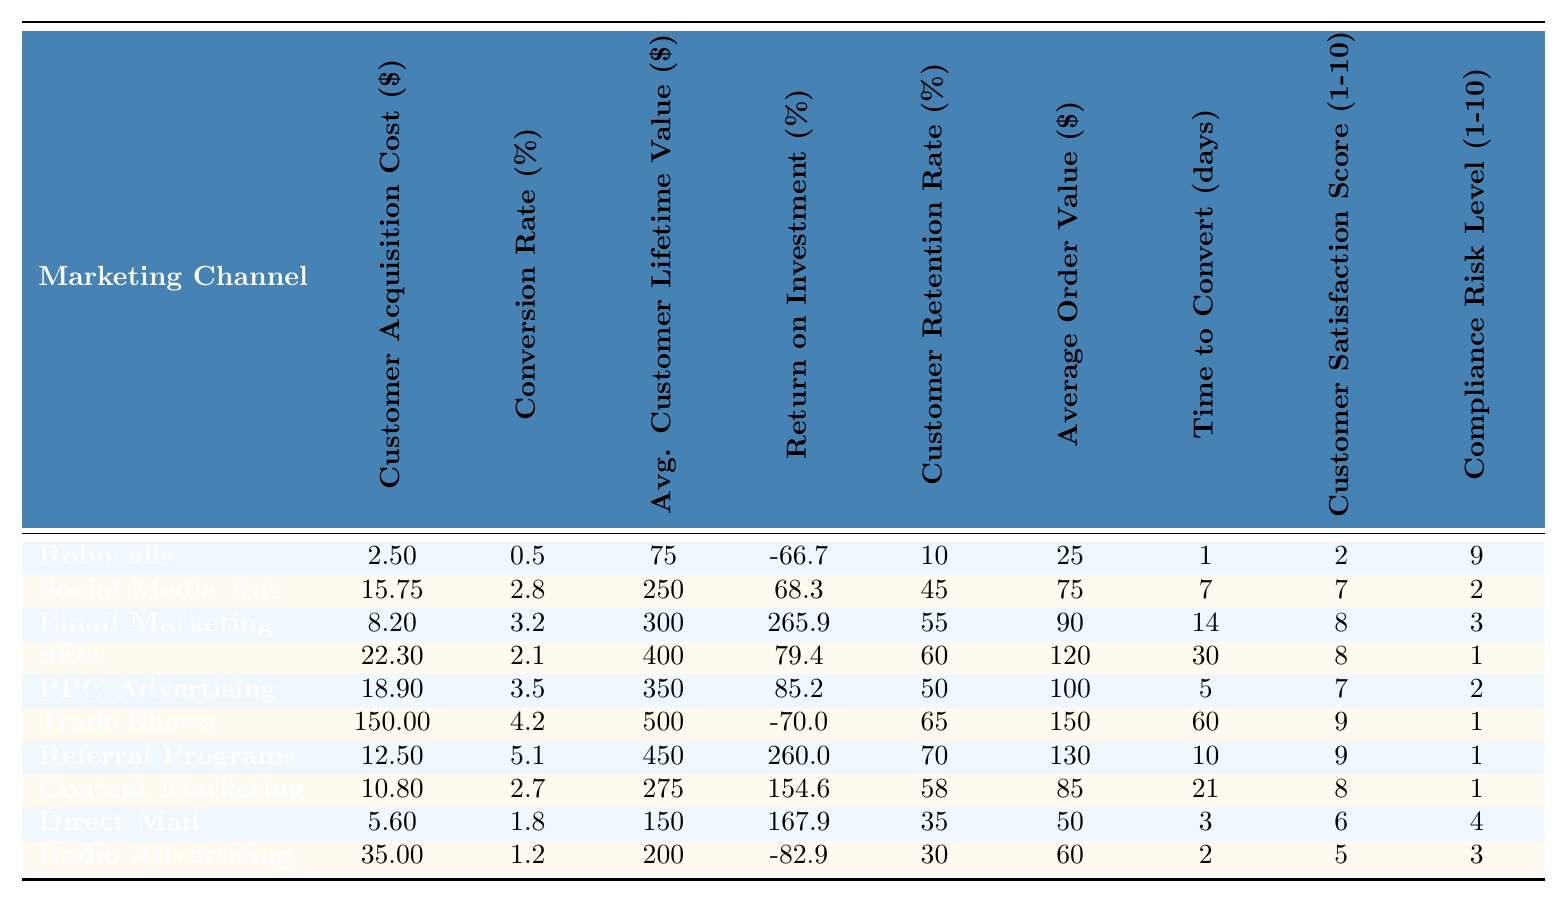What is the Customer Acquisition Cost for Robocalls? According to the table, the Customer Acquisition Cost for Robocalls is listed directly in the corresponding row, which shows the value of 2.50 dollars.
Answer: 2.50 Which marketing channel has the highest Customer Retention Rate? By examining the Customer Retention Rate column, the highest rate is found in the row for Referral Programs, which shows a rate of 70%.
Answer: Referral Programs What is the average Customer Lifetime Value for the channels listed? The Average Customer Lifetime Values for all channels are summed: 75 + 250 + 300 + 400 + 350 + 500 + 450 + 275 + 150 + 200 = 2950. Dividing this sum by the total number of channels (10) gives an average of 2950/10 = 295.
Answer: 295 Is the Return on Investment for Trade Shows positive or negative? The ROI for Trade Shows is listed as -70.0%, which indicates that it is a negative return on investment.
Answer: Negative Which marketing channel has the fastest Time to Convert? The Time to Convert for each channel shows that Robocalls have the fastest conversion time at 1 day, the shortest listed in the table.
Answer: Robocalls What is the difference in Customer Acquisition Cost between Social Media Ads and Email Marketing? The Customer Acquisition Cost for Social Media Ads is 15.75 and for Email Marketing, it is 8.20. The difference can be calculated as 15.75 - 8.20 = 7.55.
Answer: 7.55 What percentage of marketing channels have a Customer Satisfaction Score of 8 or above? There are 10 channels in total. The channels with a score of 8 or above are Email Marketing, Trade Shows, Referral Programs, Content Marketing, and Email Marketing, totaling 5 channels. Thus, the percentage is (5/10) * 100 = 50%.
Answer: 50% Which marketing channel has the lowest Average Order Value and what is that value? Looking at the Average Order Value column, Direct Mail has the lowest value at 50 dollars, which is the smallest listed.
Answer: 50 What is the average Compliance Risk Level for all marketing channels? The Compliance Risk Levels are: 9, 2, 3, 1, 2, 1, 1, 1, 4, 3. Adding these together gives: 9 + 2 + 3 + 1 + 2 + 1 + 1 + 1 + 4 + 3 = 27. Dividing by the number of channels (10) gives 27/10 = 2.7.
Answer: 2.7 Are there any marketing channels with a Conversion Rate of more than 5%? By checking the Conversion Rate column, only Referral Programs with a Conversion Rate of 5.1% exceeds 5%. Thus, the answer is yes.
Answer: Yes 